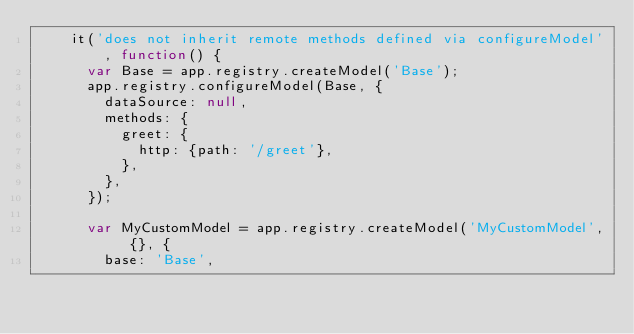Convert code to text. <code><loc_0><loc_0><loc_500><loc_500><_JavaScript_>    it('does not inherit remote methods defined via configureModel', function() {
      var Base = app.registry.createModel('Base');
      app.registry.configureModel(Base, {
        dataSource: null,
        methods: {
          greet: {
            http: {path: '/greet'},
          },
        },
      });

      var MyCustomModel = app.registry.createModel('MyCustomModel', {}, {
        base: 'Base',</code> 